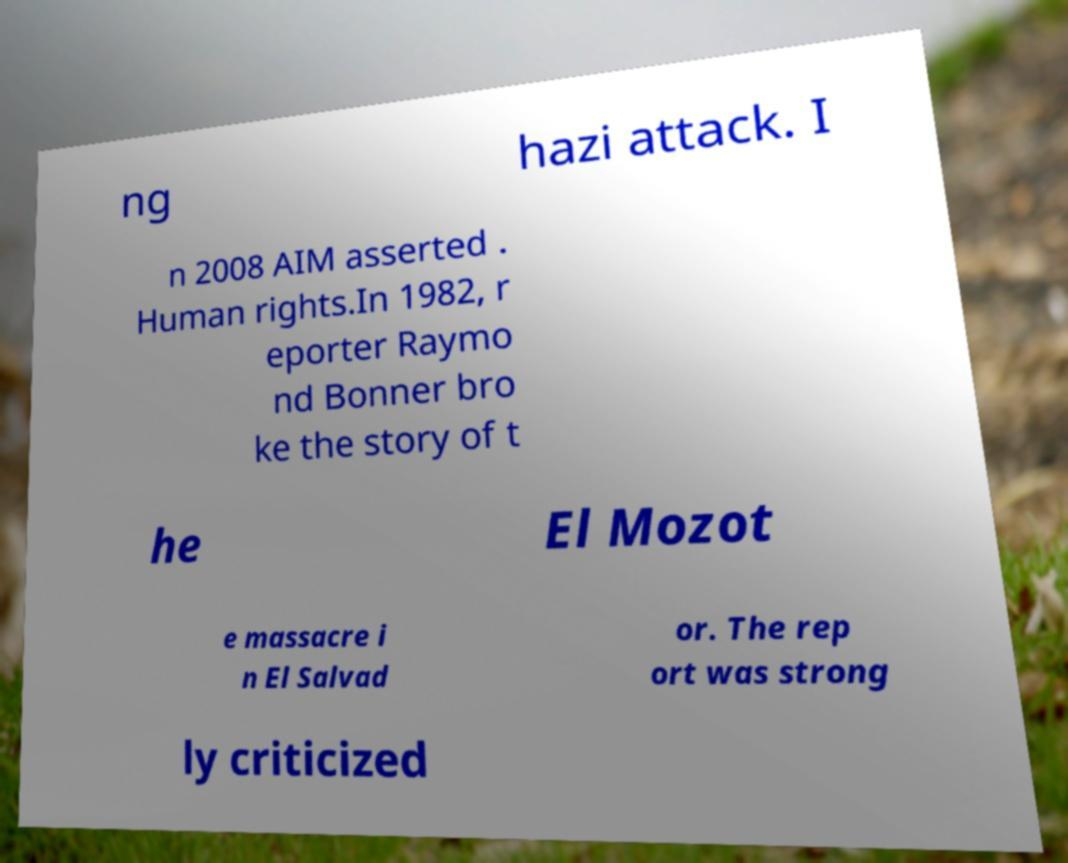Please read and relay the text visible in this image. What does it say? ng hazi attack. I n 2008 AIM asserted . Human rights.In 1982, r eporter Raymo nd Bonner bro ke the story of t he El Mozot e massacre i n El Salvad or. The rep ort was strong ly criticized 